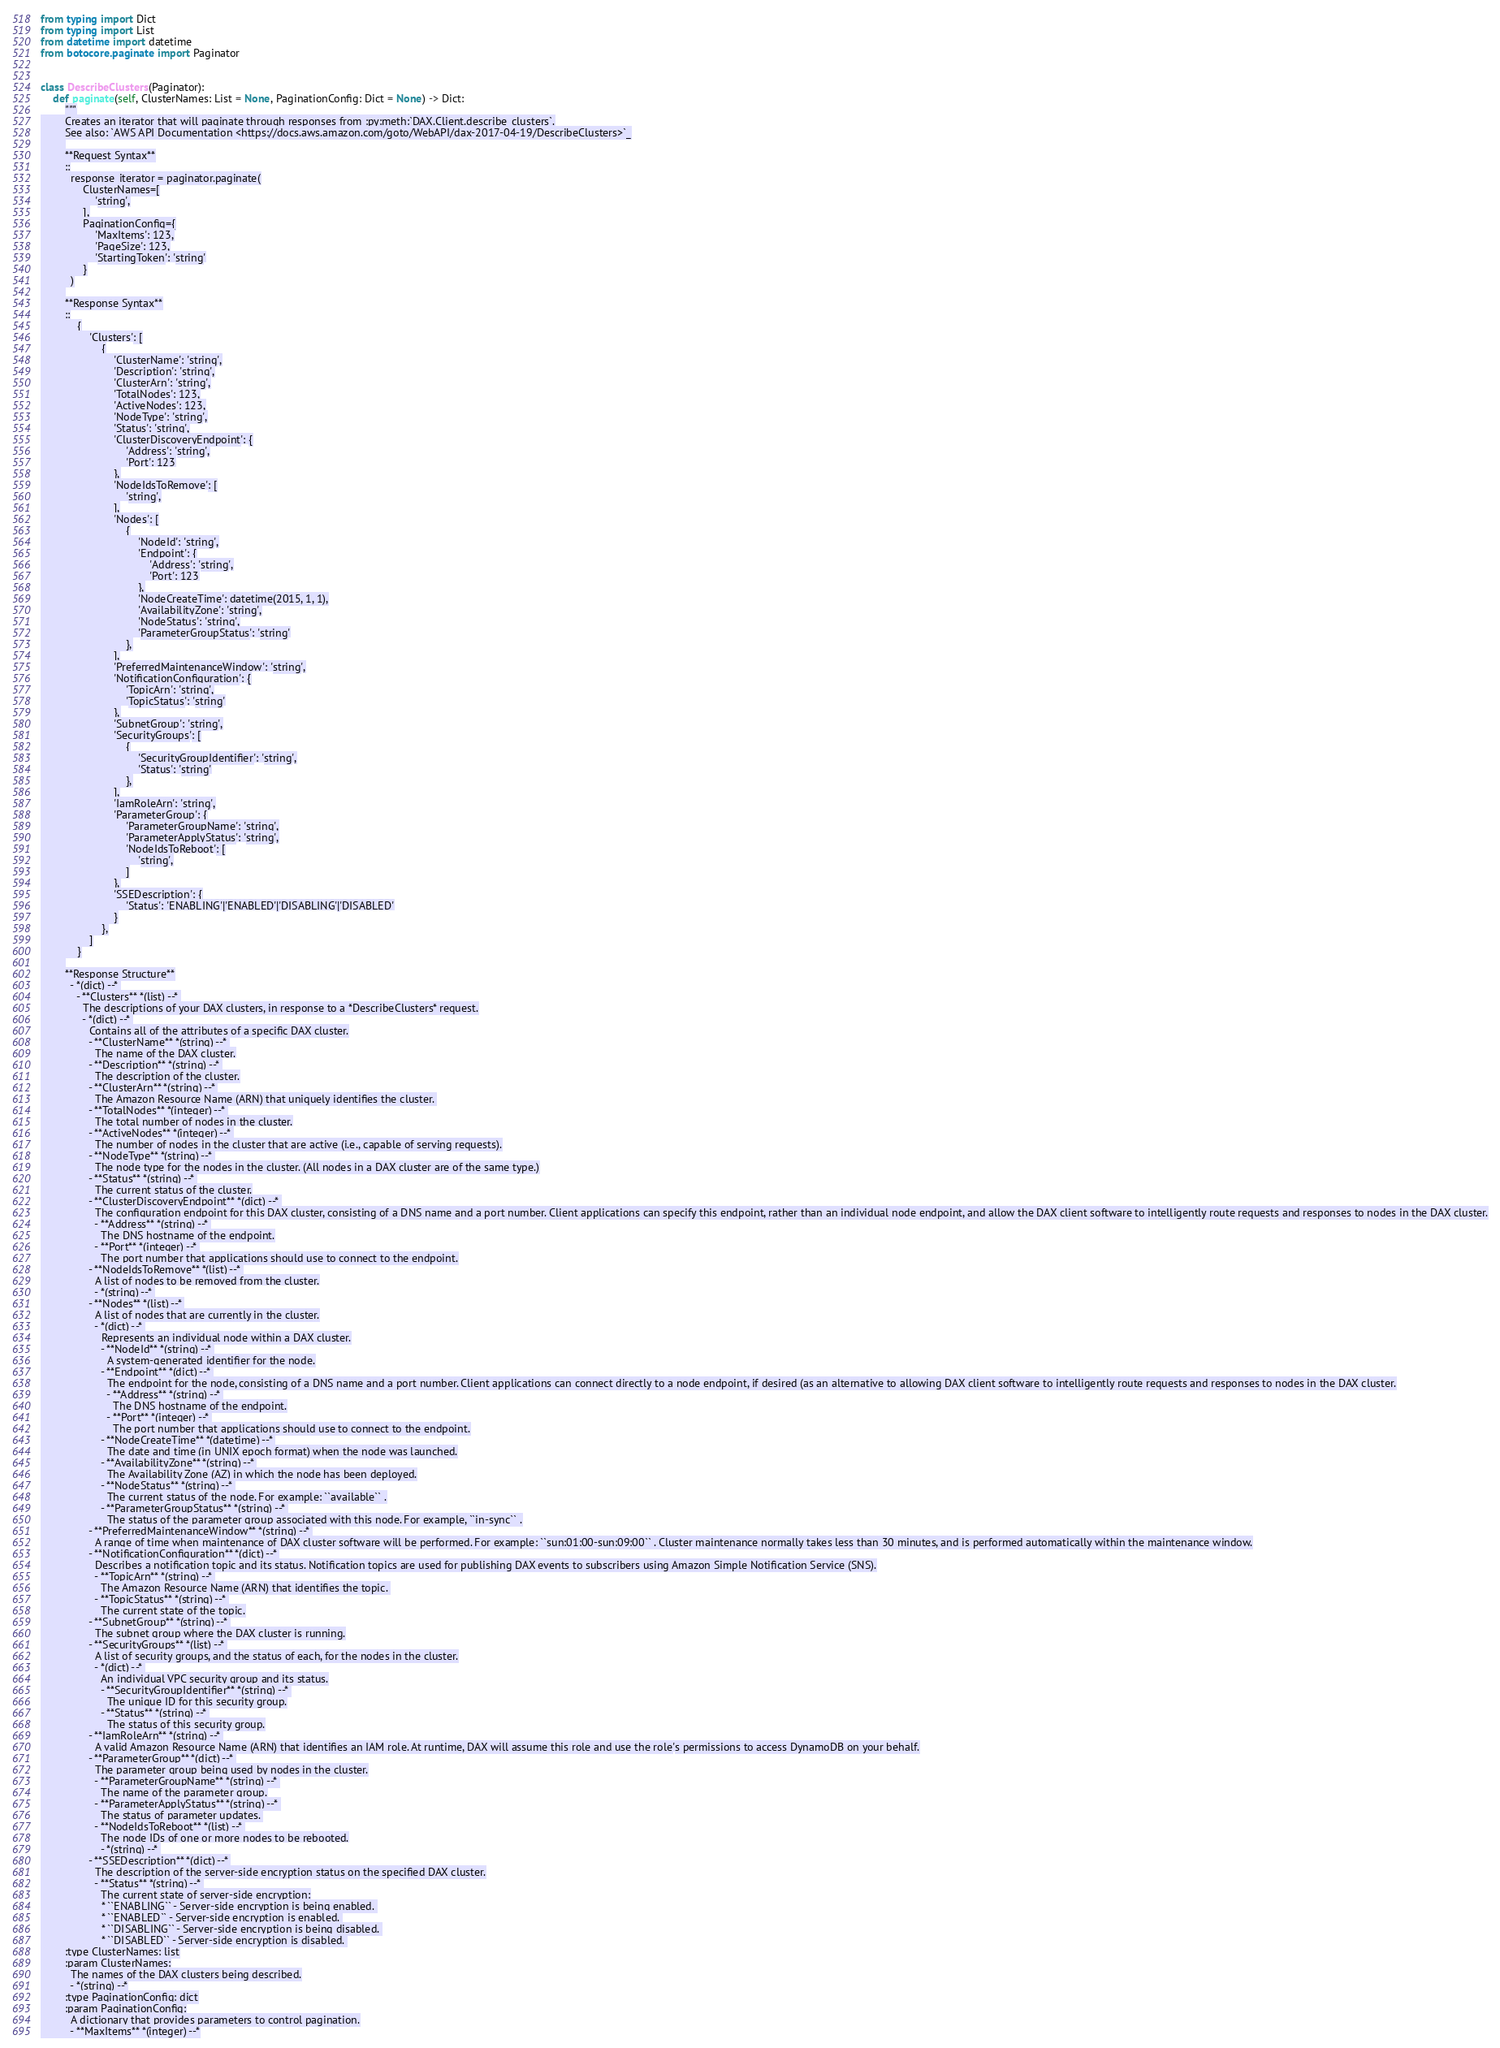Convert code to text. <code><loc_0><loc_0><loc_500><loc_500><_Python_>from typing import Dict
from typing import List
from datetime import datetime
from botocore.paginate import Paginator


class DescribeClusters(Paginator):
    def paginate(self, ClusterNames: List = None, PaginationConfig: Dict = None) -> Dict:
        """
        Creates an iterator that will paginate through responses from :py:meth:`DAX.Client.describe_clusters`.
        See also: `AWS API Documentation <https://docs.aws.amazon.com/goto/WebAPI/dax-2017-04-19/DescribeClusters>`_
        
        **Request Syntax**
        ::
          response_iterator = paginator.paginate(
              ClusterNames=[
                  'string',
              ],
              PaginationConfig={
                  'MaxItems': 123,
                  'PageSize': 123,
                  'StartingToken': 'string'
              }
          )
        
        **Response Syntax**
        ::
            {
                'Clusters': [
                    {
                        'ClusterName': 'string',
                        'Description': 'string',
                        'ClusterArn': 'string',
                        'TotalNodes': 123,
                        'ActiveNodes': 123,
                        'NodeType': 'string',
                        'Status': 'string',
                        'ClusterDiscoveryEndpoint': {
                            'Address': 'string',
                            'Port': 123
                        },
                        'NodeIdsToRemove': [
                            'string',
                        ],
                        'Nodes': [
                            {
                                'NodeId': 'string',
                                'Endpoint': {
                                    'Address': 'string',
                                    'Port': 123
                                },
                                'NodeCreateTime': datetime(2015, 1, 1),
                                'AvailabilityZone': 'string',
                                'NodeStatus': 'string',
                                'ParameterGroupStatus': 'string'
                            },
                        ],
                        'PreferredMaintenanceWindow': 'string',
                        'NotificationConfiguration': {
                            'TopicArn': 'string',
                            'TopicStatus': 'string'
                        },
                        'SubnetGroup': 'string',
                        'SecurityGroups': [
                            {
                                'SecurityGroupIdentifier': 'string',
                                'Status': 'string'
                            },
                        ],
                        'IamRoleArn': 'string',
                        'ParameterGroup': {
                            'ParameterGroupName': 'string',
                            'ParameterApplyStatus': 'string',
                            'NodeIdsToReboot': [
                                'string',
                            ]
                        },
                        'SSEDescription': {
                            'Status': 'ENABLING'|'ENABLED'|'DISABLING'|'DISABLED'
                        }
                    },
                ]
            }
        
        **Response Structure**
          - *(dict) --* 
            - **Clusters** *(list) --* 
              The descriptions of your DAX clusters, in response to a *DescribeClusters* request.
              - *(dict) --* 
                Contains all of the attributes of a specific DAX cluster.
                - **ClusterName** *(string) --* 
                  The name of the DAX cluster.
                - **Description** *(string) --* 
                  The description of the cluster.
                - **ClusterArn** *(string) --* 
                  The Amazon Resource Name (ARN) that uniquely identifies the cluster. 
                - **TotalNodes** *(integer) --* 
                  The total number of nodes in the cluster.
                - **ActiveNodes** *(integer) --* 
                  The number of nodes in the cluster that are active (i.e., capable of serving requests).
                - **NodeType** *(string) --* 
                  The node type for the nodes in the cluster. (All nodes in a DAX cluster are of the same type.)
                - **Status** *(string) --* 
                  The current status of the cluster.
                - **ClusterDiscoveryEndpoint** *(dict) --* 
                  The configuration endpoint for this DAX cluster, consisting of a DNS name and a port number. Client applications can specify this endpoint, rather than an individual node endpoint, and allow the DAX client software to intelligently route requests and responses to nodes in the DAX cluster.
                  - **Address** *(string) --* 
                    The DNS hostname of the endpoint.
                  - **Port** *(integer) --* 
                    The port number that applications should use to connect to the endpoint.
                - **NodeIdsToRemove** *(list) --* 
                  A list of nodes to be removed from the cluster.
                  - *(string) --* 
                - **Nodes** *(list) --* 
                  A list of nodes that are currently in the cluster.
                  - *(dict) --* 
                    Represents an individual node within a DAX cluster.
                    - **NodeId** *(string) --* 
                      A system-generated identifier for the node.
                    - **Endpoint** *(dict) --* 
                      The endpoint for the node, consisting of a DNS name and a port number. Client applications can connect directly to a node endpoint, if desired (as an alternative to allowing DAX client software to intelligently route requests and responses to nodes in the DAX cluster.
                      - **Address** *(string) --* 
                        The DNS hostname of the endpoint.
                      - **Port** *(integer) --* 
                        The port number that applications should use to connect to the endpoint.
                    - **NodeCreateTime** *(datetime) --* 
                      The date and time (in UNIX epoch format) when the node was launched.
                    - **AvailabilityZone** *(string) --* 
                      The Availability Zone (AZ) in which the node has been deployed.
                    - **NodeStatus** *(string) --* 
                      The current status of the node. For example: ``available`` .
                    - **ParameterGroupStatus** *(string) --* 
                      The status of the parameter group associated with this node. For example, ``in-sync`` .
                - **PreferredMaintenanceWindow** *(string) --* 
                  A range of time when maintenance of DAX cluster software will be performed. For example: ``sun:01:00-sun:09:00`` . Cluster maintenance normally takes less than 30 minutes, and is performed automatically within the maintenance window.
                - **NotificationConfiguration** *(dict) --* 
                  Describes a notification topic and its status. Notification topics are used for publishing DAX events to subscribers using Amazon Simple Notification Service (SNS).
                  - **TopicArn** *(string) --* 
                    The Amazon Resource Name (ARN) that identifies the topic. 
                  - **TopicStatus** *(string) --* 
                    The current state of the topic.
                - **SubnetGroup** *(string) --* 
                  The subnet group where the DAX cluster is running.
                - **SecurityGroups** *(list) --* 
                  A list of security groups, and the status of each, for the nodes in the cluster.
                  - *(dict) --* 
                    An individual VPC security group and its status.
                    - **SecurityGroupIdentifier** *(string) --* 
                      The unique ID for this security group.
                    - **Status** *(string) --* 
                      The status of this security group.
                - **IamRoleArn** *(string) --* 
                  A valid Amazon Resource Name (ARN) that identifies an IAM role. At runtime, DAX will assume this role and use the role's permissions to access DynamoDB on your behalf.
                - **ParameterGroup** *(dict) --* 
                  The parameter group being used by nodes in the cluster.
                  - **ParameterGroupName** *(string) --* 
                    The name of the parameter group.
                  - **ParameterApplyStatus** *(string) --* 
                    The status of parameter updates. 
                  - **NodeIdsToReboot** *(list) --* 
                    The node IDs of one or more nodes to be rebooted.
                    - *(string) --* 
                - **SSEDescription** *(dict) --* 
                  The description of the server-side encryption status on the specified DAX cluster.
                  - **Status** *(string) --* 
                    The current state of server-side encryption:
                    * ``ENABLING`` - Server-side encryption is being enabled. 
                    * ``ENABLED`` - Server-side encryption is enabled. 
                    * ``DISABLING`` - Server-side encryption is being disabled. 
                    * ``DISABLED`` - Server-side encryption is disabled. 
        :type ClusterNames: list
        :param ClusterNames:
          The names of the DAX clusters being described.
          - *(string) --*
        :type PaginationConfig: dict
        :param PaginationConfig:
          A dictionary that provides parameters to control pagination.
          - **MaxItems** *(integer) --*</code> 